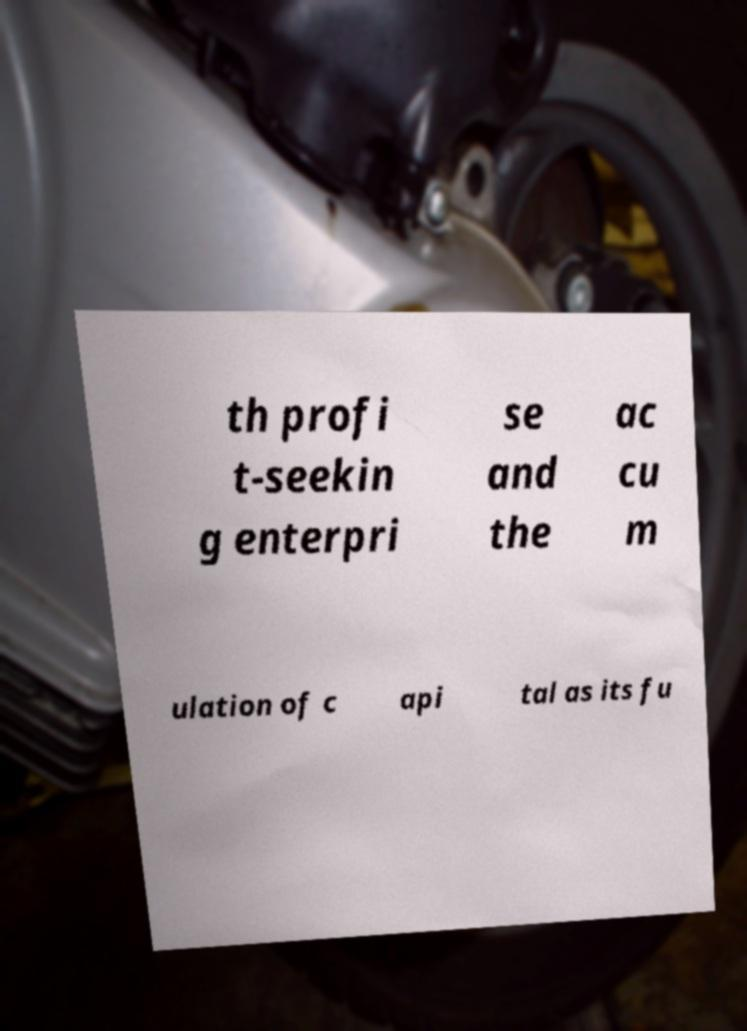Can you accurately transcribe the text from the provided image for me? th profi t-seekin g enterpri se and the ac cu m ulation of c api tal as its fu 